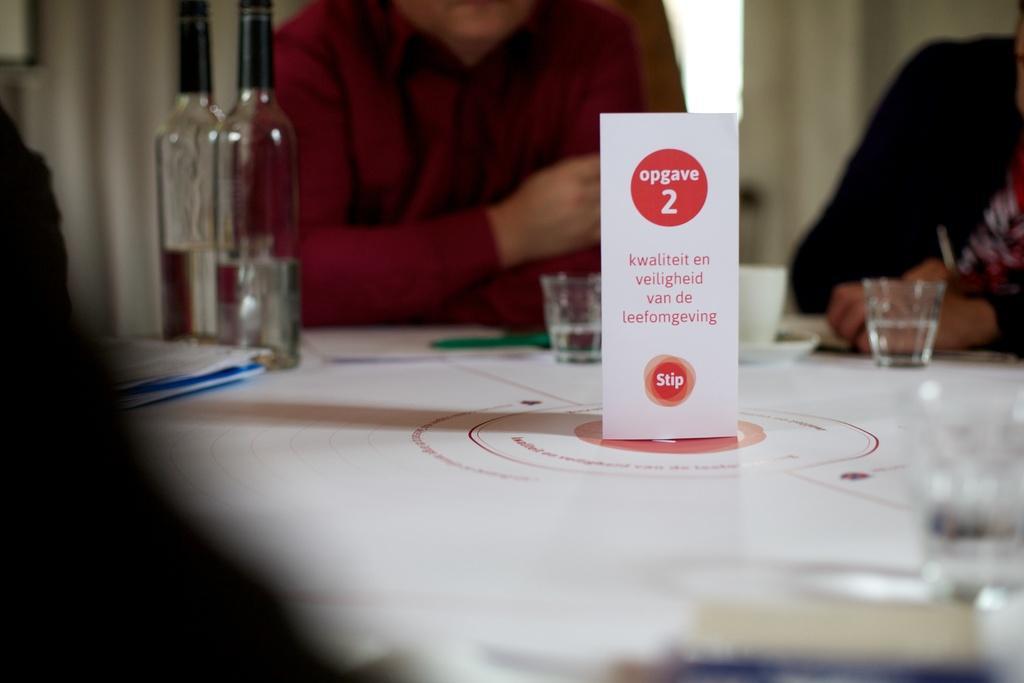Could you give a brief overview of what you see in this image? In this picture there is a paper placed on the table on which some bottles, glasses were there. There are some people sitting around the table. 